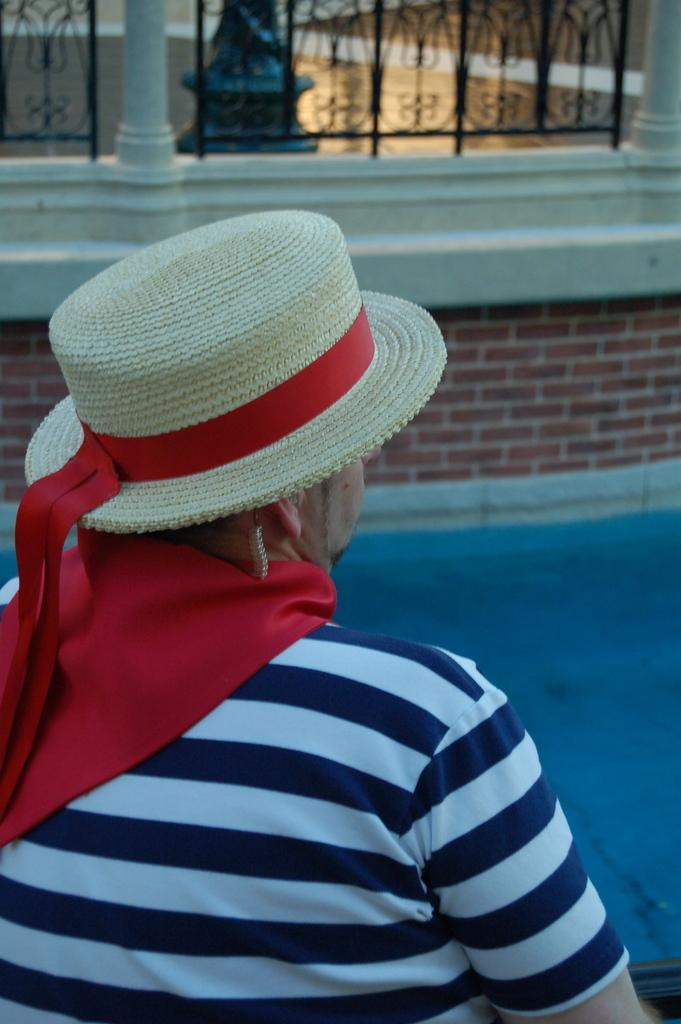Who or what is present in the image? There is a person in the image. What is the person wearing on their head? The person is wearing a hat. What type of water feature can be seen in the image? There is a swimming pool in the image. What architectural element is visible in the image? There is a wall in the image. What structural supports are present in the image? There are pillars in the image. What type of barrier is present in the image? There is a metal fence in the image. What type of credit card does the person in the image use to pay for their swimming lessons? There is no credit card or mention of swimming lessons in the image. 